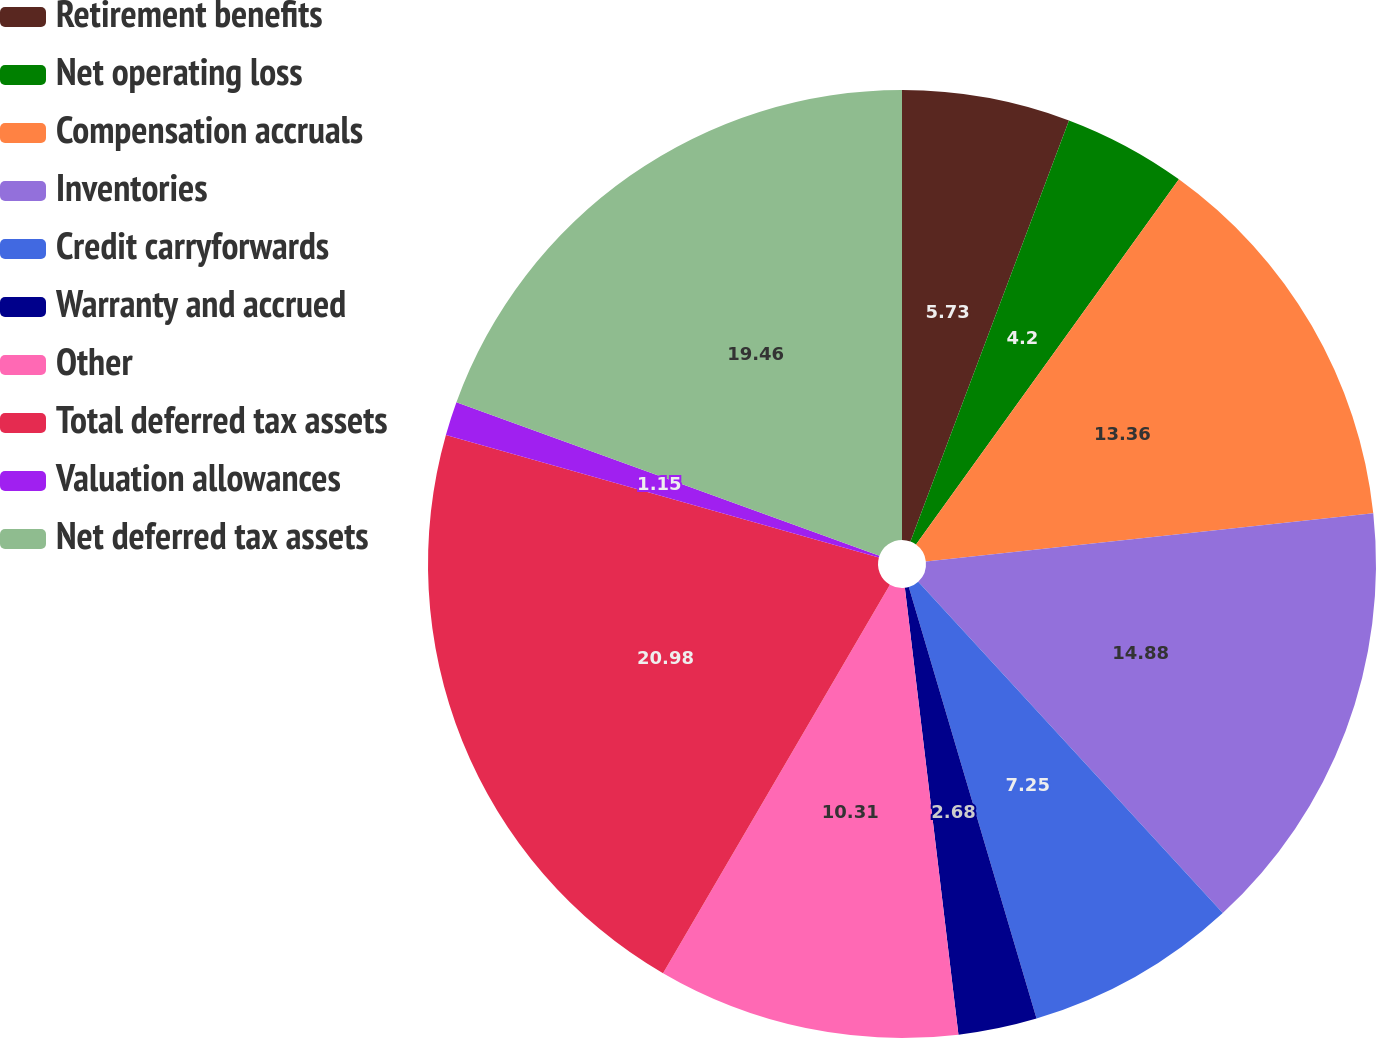<chart> <loc_0><loc_0><loc_500><loc_500><pie_chart><fcel>Retirement benefits<fcel>Net operating loss<fcel>Compensation accruals<fcel>Inventories<fcel>Credit carryforwards<fcel>Warranty and accrued<fcel>Other<fcel>Total deferred tax assets<fcel>Valuation allowances<fcel>Net deferred tax assets<nl><fcel>5.73%<fcel>4.2%<fcel>13.36%<fcel>14.88%<fcel>7.25%<fcel>2.68%<fcel>10.31%<fcel>20.98%<fcel>1.15%<fcel>19.46%<nl></chart> 